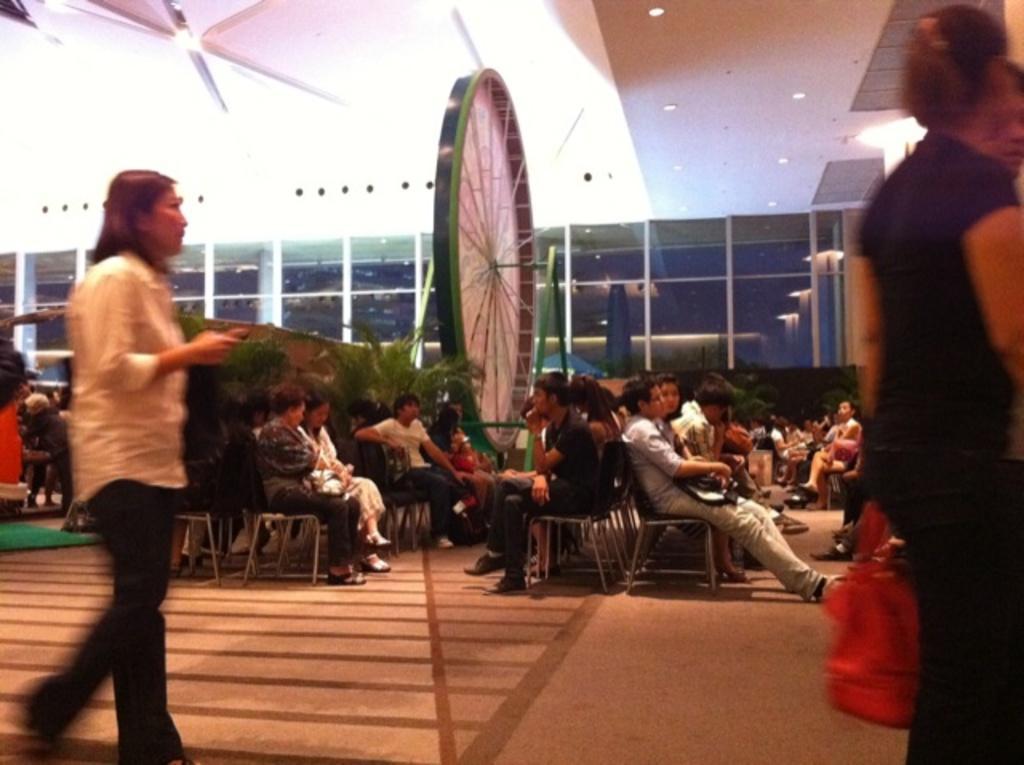Please provide a concise description of this image. This image consists of many people sitting in the chairs. On the left and right, there are two women walking. At the bottom, there is a floor. At the top, there is a roof along with the lights. In the background, there are glass windows. In the middle, there is a circular object and there are plants. 